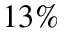<formula> <loc_0><loc_0><loc_500><loc_500>1 3 \%</formula> 